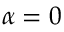Convert formula to latex. <formula><loc_0><loc_0><loc_500><loc_500>\alpha = 0</formula> 